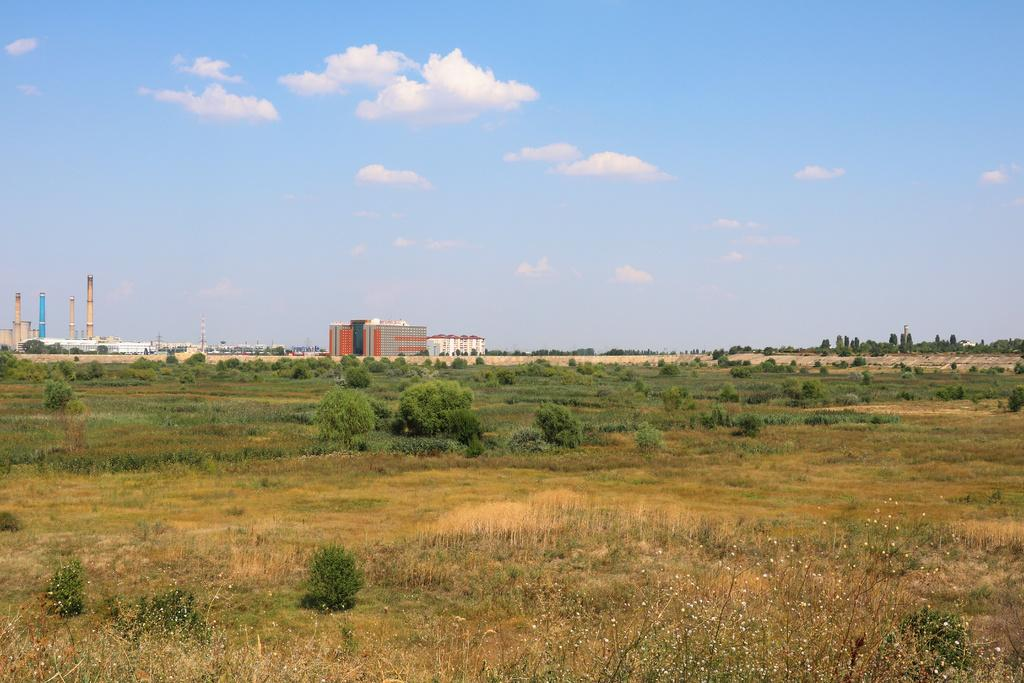What type of surface is on the ground in the image? There is grass on the ground in the image. What type of vegetation can be seen in the image? There are green plants in the image. What type of structures are visible in the image? There are buildings in the image. What is visible in the background of the image? The sky is visible in the background of the image. Can you see a plate being used for a game of volleyball in the image? There is no plate or game of volleyball present in the image. What type of twig can be seen growing from the grass in the image? There is no twig visible in the image; only grass and green plants are present. 